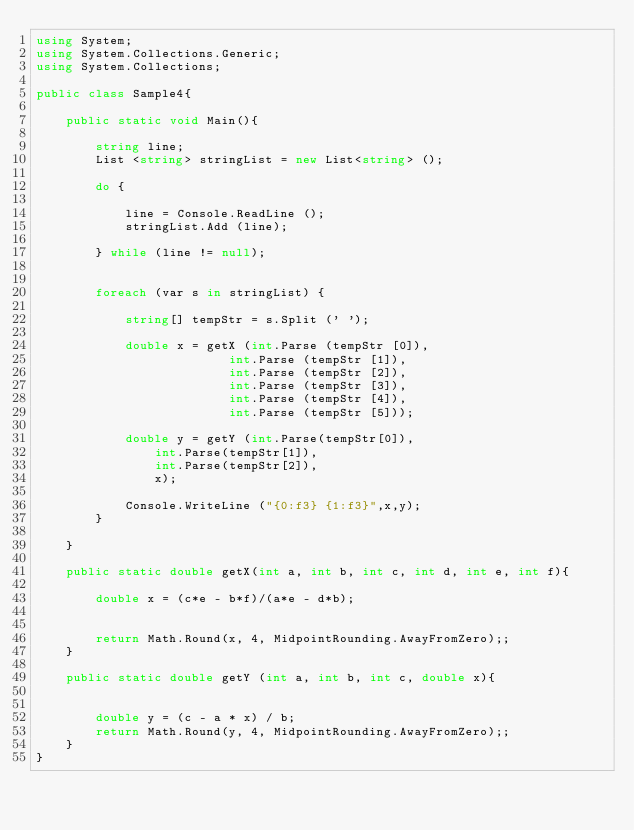Convert code to text. <code><loc_0><loc_0><loc_500><loc_500><_C#_>using System;
using System.Collections.Generic;
using System.Collections;

public class Sample4{

	public static void Main(){

		string line;
		List <string> stringList = new List<string> ();

		do {

			line = Console.ReadLine ();
			stringList.Add (line);

		} while (line != null);


		foreach (var s in stringList) {

			string[] tempStr = s.Split (' ');

			double x = getX (int.Parse (tempStr [0]),
				          int.Parse (tempStr [1]),
				          int.Parse (tempStr [2]),
				          int.Parse (tempStr [3]),
				          int.Parse (tempStr [4]),
				          int.Parse (tempStr [5]));

			double y = getY (int.Parse(tempStr[0]),
				int.Parse(tempStr[1]),
				int.Parse(tempStr[2]),
				x);

			Console.WriteLine ("{0:f3} {1:f3}",x,y);
		}

	}

	public static double getX(int a, int b, int c, int d, int e, int f){

		double x = (c*e - b*f)/(a*e - d*b);


		return Math.Round(x, 4, MidpointRounding.AwayFromZero);;
	}

	public static double getY (int a, int b, int c, double x){


		double y = (c - a * x) / b;
		return Math.Round(y, 4, MidpointRounding.AwayFromZero);;
	}
}</code> 